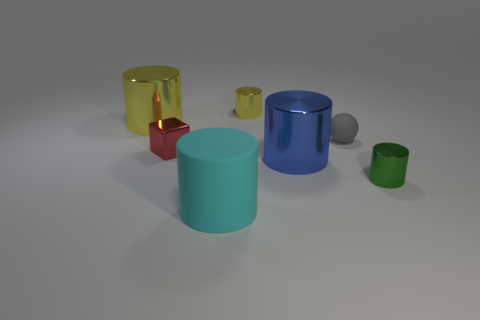Subtract all large rubber cylinders. How many cylinders are left? 4 Subtract all cyan cylinders. How many cylinders are left? 4 Subtract 1 cylinders. How many cylinders are left? 4 Subtract all red cylinders. Subtract all purple balls. How many cylinders are left? 5 Add 1 large metallic objects. How many objects exist? 8 Subtract all spheres. How many objects are left? 6 Subtract all tiny red metallic blocks. Subtract all small blue blocks. How many objects are left? 6 Add 5 big shiny cylinders. How many big shiny cylinders are left? 7 Add 5 blocks. How many blocks exist? 6 Subtract 0 green spheres. How many objects are left? 7 